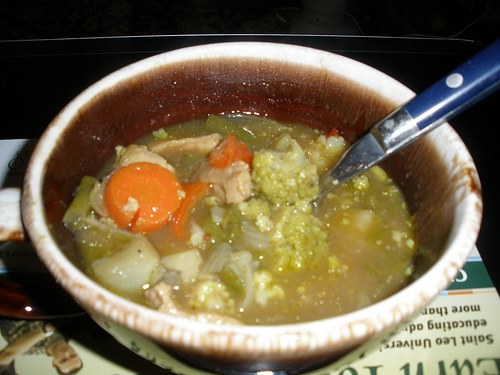Do you see any food to the left of the carrot that looks round? No, there doesn't appear to be any food to the left of the round-shaped carrot. 